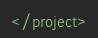Convert code to text. <code><loc_0><loc_0><loc_500><loc_500><_XML_>

</project></code> 